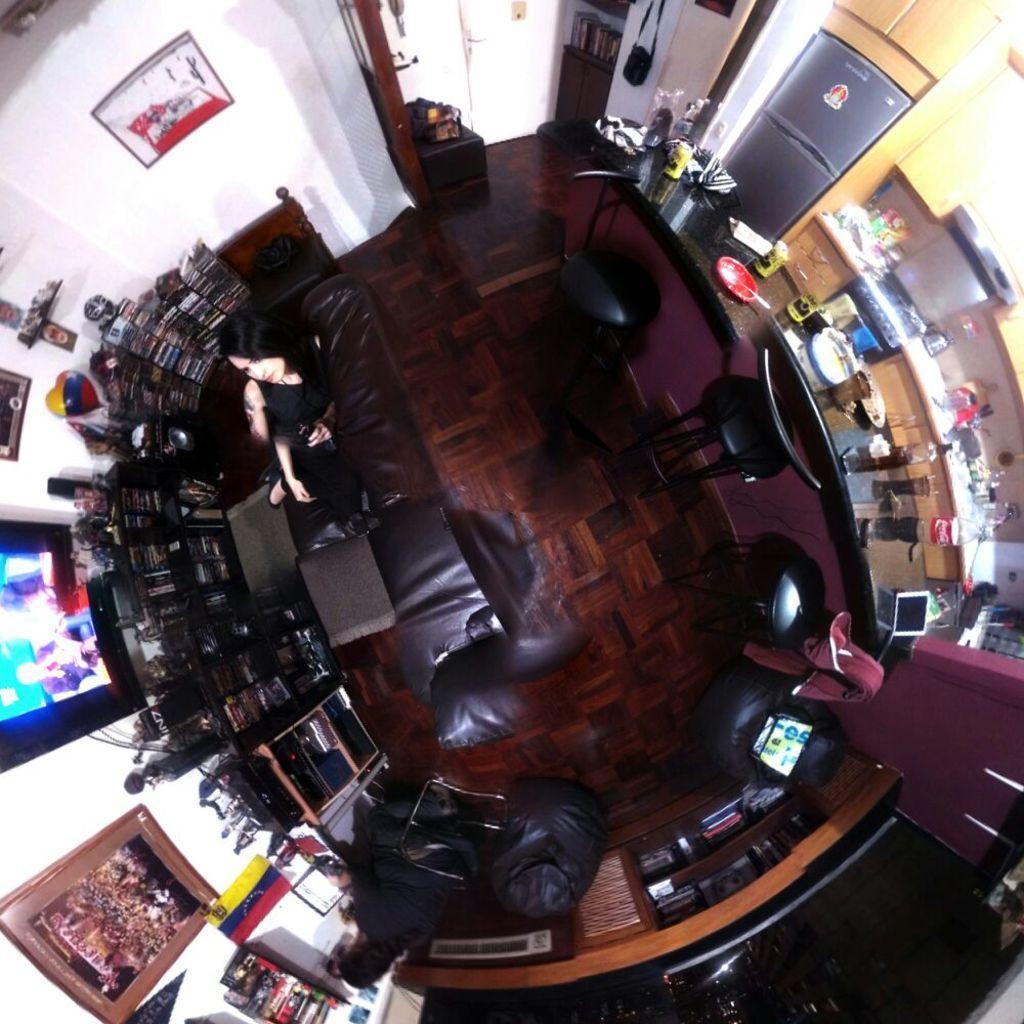Can you describe this image briefly? In these racks there are books and things. Pictures are on the wall. On this table there are objects. In-front of this table there are chairs. Here we can see a person and couch. 